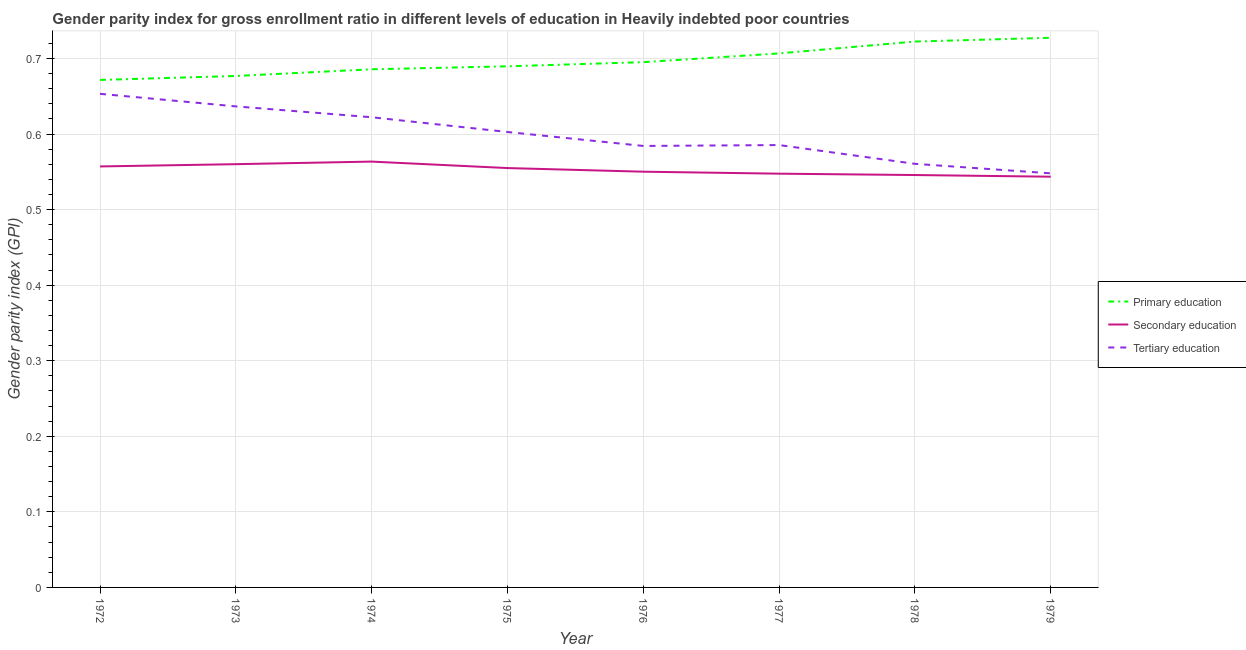What is the gender parity index in secondary education in 1976?
Provide a succinct answer. 0.55. Across all years, what is the maximum gender parity index in secondary education?
Keep it short and to the point. 0.56. Across all years, what is the minimum gender parity index in secondary education?
Provide a succinct answer. 0.54. In which year was the gender parity index in tertiary education minimum?
Make the answer very short. 1979. What is the total gender parity index in tertiary education in the graph?
Make the answer very short. 4.79. What is the difference between the gender parity index in secondary education in 1972 and that in 1974?
Your answer should be very brief. -0.01. What is the difference between the gender parity index in tertiary education in 1977 and the gender parity index in secondary education in 1973?
Your response must be concise. 0.03. What is the average gender parity index in tertiary education per year?
Keep it short and to the point. 0.6. In the year 1972, what is the difference between the gender parity index in secondary education and gender parity index in tertiary education?
Make the answer very short. -0.1. What is the ratio of the gender parity index in tertiary education in 1973 to that in 1976?
Ensure brevity in your answer.  1.09. Is the gender parity index in secondary education in 1974 less than that in 1976?
Your answer should be compact. No. Is the difference between the gender parity index in primary education in 1972 and 1977 greater than the difference between the gender parity index in tertiary education in 1972 and 1977?
Offer a terse response. No. What is the difference between the highest and the second highest gender parity index in tertiary education?
Provide a succinct answer. 0.02. What is the difference between the highest and the lowest gender parity index in secondary education?
Give a very brief answer. 0.02. Is the sum of the gender parity index in primary education in 1978 and 1979 greater than the maximum gender parity index in tertiary education across all years?
Provide a short and direct response. Yes. Is it the case that in every year, the sum of the gender parity index in primary education and gender parity index in secondary education is greater than the gender parity index in tertiary education?
Your answer should be compact. Yes. Is the gender parity index in primary education strictly less than the gender parity index in secondary education over the years?
Your answer should be compact. No. What is the difference between two consecutive major ticks on the Y-axis?
Give a very brief answer. 0.1. Are the values on the major ticks of Y-axis written in scientific E-notation?
Keep it short and to the point. No. Does the graph contain any zero values?
Make the answer very short. No. Where does the legend appear in the graph?
Provide a short and direct response. Center right. How are the legend labels stacked?
Provide a short and direct response. Vertical. What is the title of the graph?
Your answer should be very brief. Gender parity index for gross enrollment ratio in different levels of education in Heavily indebted poor countries. What is the label or title of the X-axis?
Your response must be concise. Year. What is the label or title of the Y-axis?
Ensure brevity in your answer.  Gender parity index (GPI). What is the Gender parity index (GPI) in Primary education in 1972?
Provide a succinct answer. 0.67. What is the Gender parity index (GPI) of Secondary education in 1972?
Give a very brief answer. 0.56. What is the Gender parity index (GPI) in Tertiary education in 1972?
Keep it short and to the point. 0.65. What is the Gender parity index (GPI) in Primary education in 1973?
Ensure brevity in your answer.  0.68. What is the Gender parity index (GPI) in Secondary education in 1973?
Offer a very short reply. 0.56. What is the Gender parity index (GPI) of Tertiary education in 1973?
Your answer should be very brief. 0.64. What is the Gender parity index (GPI) in Primary education in 1974?
Offer a very short reply. 0.69. What is the Gender parity index (GPI) in Secondary education in 1974?
Ensure brevity in your answer.  0.56. What is the Gender parity index (GPI) in Tertiary education in 1974?
Keep it short and to the point. 0.62. What is the Gender parity index (GPI) of Primary education in 1975?
Offer a very short reply. 0.69. What is the Gender parity index (GPI) of Secondary education in 1975?
Give a very brief answer. 0.56. What is the Gender parity index (GPI) of Tertiary education in 1975?
Offer a terse response. 0.6. What is the Gender parity index (GPI) in Primary education in 1976?
Give a very brief answer. 0.7. What is the Gender parity index (GPI) in Secondary education in 1976?
Give a very brief answer. 0.55. What is the Gender parity index (GPI) of Tertiary education in 1976?
Ensure brevity in your answer.  0.58. What is the Gender parity index (GPI) in Primary education in 1977?
Provide a succinct answer. 0.71. What is the Gender parity index (GPI) in Secondary education in 1977?
Your response must be concise. 0.55. What is the Gender parity index (GPI) of Tertiary education in 1977?
Offer a terse response. 0.59. What is the Gender parity index (GPI) in Primary education in 1978?
Ensure brevity in your answer.  0.72. What is the Gender parity index (GPI) of Secondary education in 1978?
Make the answer very short. 0.55. What is the Gender parity index (GPI) of Tertiary education in 1978?
Offer a very short reply. 0.56. What is the Gender parity index (GPI) in Primary education in 1979?
Provide a short and direct response. 0.73. What is the Gender parity index (GPI) in Secondary education in 1979?
Your response must be concise. 0.54. What is the Gender parity index (GPI) in Tertiary education in 1979?
Keep it short and to the point. 0.55. Across all years, what is the maximum Gender parity index (GPI) in Primary education?
Provide a succinct answer. 0.73. Across all years, what is the maximum Gender parity index (GPI) of Secondary education?
Offer a terse response. 0.56. Across all years, what is the maximum Gender parity index (GPI) in Tertiary education?
Your response must be concise. 0.65. Across all years, what is the minimum Gender parity index (GPI) of Primary education?
Your answer should be very brief. 0.67. Across all years, what is the minimum Gender parity index (GPI) of Secondary education?
Provide a short and direct response. 0.54. Across all years, what is the minimum Gender parity index (GPI) of Tertiary education?
Your answer should be compact. 0.55. What is the total Gender parity index (GPI) of Primary education in the graph?
Your response must be concise. 5.58. What is the total Gender parity index (GPI) in Secondary education in the graph?
Make the answer very short. 4.42. What is the total Gender parity index (GPI) in Tertiary education in the graph?
Your answer should be compact. 4.79. What is the difference between the Gender parity index (GPI) of Primary education in 1972 and that in 1973?
Make the answer very short. -0.01. What is the difference between the Gender parity index (GPI) of Secondary education in 1972 and that in 1973?
Offer a terse response. -0. What is the difference between the Gender parity index (GPI) in Tertiary education in 1972 and that in 1973?
Your answer should be very brief. 0.02. What is the difference between the Gender parity index (GPI) of Primary education in 1972 and that in 1974?
Ensure brevity in your answer.  -0.01. What is the difference between the Gender parity index (GPI) in Secondary education in 1972 and that in 1974?
Your response must be concise. -0.01. What is the difference between the Gender parity index (GPI) of Tertiary education in 1972 and that in 1974?
Your response must be concise. 0.03. What is the difference between the Gender parity index (GPI) in Primary education in 1972 and that in 1975?
Your answer should be very brief. -0.02. What is the difference between the Gender parity index (GPI) in Secondary education in 1972 and that in 1975?
Provide a short and direct response. 0. What is the difference between the Gender parity index (GPI) in Tertiary education in 1972 and that in 1975?
Give a very brief answer. 0.05. What is the difference between the Gender parity index (GPI) of Primary education in 1972 and that in 1976?
Make the answer very short. -0.02. What is the difference between the Gender parity index (GPI) in Secondary education in 1972 and that in 1976?
Your response must be concise. 0.01. What is the difference between the Gender parity index (GPI) in Tertiary education in 1972 and that in 1976?
Keep it short and to the point. 0.07. What is the difference between the Gender parity index (GPI) in Primary education in 1972 and that in 1977?
Your response must be concise. -0.04. What is the difference between the Gender parity index (GPI) in Secondary education in 1972 and that in 1977?
Make the answer very short. 0.01. What is the difference between the Gender parity index (GPI) of Tertiary education in 1972 and that in 1977?
Your response must be concise. 0.07. What is the difference between the Gender parity index (GPI) in Primary education in 1972 and that in 1978?
Make the answer very short. -0.05. What is the difference between the Gender parity index (GPI) in Secondary education in 1972 and that in 1978?
Provide a short and direct response. 0.01. What is the difference between the Gender parity index (GPI) in Tertiary education in 1972 and that in 1978?
Provide a succinct answer. 0.09. What is the difference between the Gender parity index (GPI) of Primary education in 1972 and that in 1979?
Give a very brief answer. -0.06. What is the difference between the Gender parity index (GPI) of Secondary education in 1972 and that in 1979?
Keep it short and to the point. 0.01. What is the difference between the Gender parity index (GPI) in Tertiary education in 1972 and that in 1979?
Make the answer very short. 0.11. What is the difference between the Gender parity index (GPI) in Primary education in 1973 and that in 1974?
Your response must be concise. -0.01. What is the difference between the Gender parity index (GPI) in Secondary education in 1973 and that in 1974?
Your response must be concise. -0. What is the difference between the Gender parity index (GPI) in Tertiary education in 1973 and that in 1974?
Offer a very short reply. 0.01. What is the difference between the Gender parity index (GPI) in Primary education in 1973 and that in 1975?
Ensure brevity in your answer.  -0.01. What is the difference between the Gender parity index (GPI) of Secondary education in 1973 and that in 1975?
Offer a very short reply. 0.01. What is the difference between the Gender parity index (GPI) of Tertiary education in 1973 and that in 1975?
Give a very brief answer. 0.03. What is the difference between the Gender parity index (GPI) of Primary education in 1973 and that in 1976?
Offer a terse response. -0.02. What is the difference between the Gender parity index (GPI) of Secondary education in 1973 and that in 1976?
Your answer should be very brief. 0.01. What is the difference between the Gender parity index (GPI) of Tertiary education in 1973 and that in 1976?
Your answer should be compact. 0.05. What is the difference between the Gender parity index (GPI) of Primary education in 1973 and that in 1977?
Offer a terse response. -0.03. What is the difference between the Gender parity index (GPI) in Secondary education in 1973 and that in 1977?
Ensure brevity in your answer.  0.01. What is the difference between the Gender parity index (GPI) of Tertiary education in 1973 and that in 1977?
Offer a very short reply. 0.05. What is the difference between the Gender parity index (GPI) in Primary education in 1973 and that in 1978?
Offer a terse response. -0.05. What is the difference between the Gender parity index (GPI) in Secondary education in 1973 and that in 1978?
Provide a short and direct response. 0.01. What is the difference between the Gender parity index (GPI) of Tertiary education in 1973 and that in 1978?
Offer a terse response. 0.08. What is the difference between the Gender parity index (GPI) of Primary education in 1973 and that in 1979?
Offer a very short reply. -0.05. What is the difference between the Gender parity index (GPI) of Secondary education in 1973 and that in 1979?
Offer a very short reply. 0.02. What is the difference between the Gender parity index (GPI) in Tertiary education in 1973 and that in 1979?
Your answer should be very brief. 0.09. What is the difference between the Gender parity index (GPI) of Primary education in 1974 and that in 1975?
Offer a very short reply. -0. What is the difference between the Gender parity index (GPI) in Secondary education in 1974 and that in 1975?
Offer a very short reply. 0.01. What is the difference between the Gender parity index (GPI) in Tertiary education in 1974 and that in 1975?
Your answer should be compact. 0.02. What is the difference between the Gender parity index (GPI) of Primary education in 1974 and that in 1976?
Give a very brief answer. -0.01. What is the difference between the Gender parity index (GPI) of Secondary education in 1974 and that in 1976?
Keep it short and to the point. 0.01. What is the difference between the Gender parity index (GPI) in Tertiary education in 1974 and that in 1976?
Provide a succinct answer. 0.04. What is the difference between the Gender parity index (GPI) of Primary education in 1974 and that in 1977?
Your response must be concise. -0.02. What is the difference between the Gender parity index (GPI) of Secondary education in 1974 and that in 1977?
Your answer should be compact. 0.02. What is the difference between the Gender parity index (GPI) in Tertiary education in 1974 and that in 1977?
Ensure brevity in your answer.  0.04. What is the difference between the Gender parity index (GPI) of Primary education in 1974 and that in 1978?
Ensure brevity in your answer.  -0.04. What is the difference between the Gender parity index (GPI) of Secondary education in 1974 and that in 1978?
Offer a very short reply. 0.02. What is the difference between the Gender parity index (GPI) in Tertiary education in 1974 and that in 1978?
Provide a succinct answer. 0.06. What is the difference between the Gender parity index (GPI) of Primary education in 1974 and that in 1979?
Keep it short and to the point. -0.04. What is the difference between the Gender parity index (GPI) of Tertiary education in 1974 and that in 1979?
Keep it short and to the point. 0.07. What is the difference between the Gender parity index (GPI) in Primary education in 1975 and that in 1976?
Make the answer very short. -0.01. What is the difference between the Gender parity index (GPI) in Secondary education in 1975 and that in 1976?
Give a very brief answer. 0. What is the difference between the Gender parity index (GPI) of Tertiary education in 1975 and that in 1976?
Ensure brevity in your answer.  0.02. What is the difference between the Gender parity index (GPI) in Primary education in 1975 and that in 1977?
Offer a terse response. -0.02. What is the difference between the Gender parity index (GPI) of Secondary education in 1975 and that in 1977?
Your answer should be compact. 0.01. What is the difference between the Gender parity index (GPI) of Tertiary education in 1975 and that in 1977?
Offer a terse response. 0.02. What is the difference between the Gender parity index (GPI) of Primary education in 1975 and that in 1978?
Make the answer very short. -0.03. What is the difference between the Gender parity index (GPI) of Secondary education in 1975 and that in 1978?
Your response must be concise. 0.01. What is the difference between the Gender parity index (GPI) in Tertiary education in 1975 and that in 1978?
Ensure brevity in your answer.  0.04. What is the difference between the Gender parity index (GPI) in Primary education in 1975 and that in 1979?
Ensure brevity in your answer.  -0.04. What is the difference between the Gender parity index (GPI) of Secondary education in 1975 and that in 1979?
Give a very brief answer. 0.01. What is the difference between the Gender parity index (GPI) in Tertiary education in 1975 and that in 1979?
Offer a very short reply. 0.05. What is the difference between the Gender parity index (GPI) in Primary education in 1976 and that in 1977?
Give a very brief answer. -0.01. What is the difference between the Gender parity index (GPI) of Secondary education in 1976 and that in 1977?
Give a very brief answer. 0. What is the difference between the Gender parity index (GPI) in Tertiary education in 1976 and that in 1977?
Your answer should be very brief. -0. What is the difference between the Gender parity index (GPI) in Primary education in 1976 and that in 1978?
Keep it short and to the point. -0.03. What is the difference between the Gender parity index (GPI) of Secondary education in 1976 and that in 1978?
Ensure brevity in your answer.  0. What is the difference between the Gender parity index (GPI) of Tertiary education in 1976 and that in 1978?
Give a very brief answer. 0.02. What is the difference between the Gender parity index (GPI) in Primary education in 1976 and that in 1979?
Provide a short and direct response. -0.03. What is the difference between the Gender parity index (GPI) of Secondary education in 1976 and that in 1979?
Give a very brief answer. 0.01. What is the difference between the Gender parity index (GPI) of Tertiary education in 1976 and that in 1979?
Provide a succinct answer. 0.04. What is the difference between the Gender parity index (GPI) in Primary education in 1977 and that in 1978?
Keep it short and to the point. -0.02. What is the difference between the Gender parity index (GPI) of Secondary education in 1977 and that in 1978?
Ensure brevity in your answer.  0. What is the difference between the Gender parity index (GPI) in Tertiary education in 1977 and that in 1978?
Give a very brief answer. 0.02. What is the difference between the Gender parity index (GPI) of Primary education in 1977 and that in 1979?
Your response must be concise. -0.02. What is the difference between the Gender parity index (GPI) of Secondary education in 1977 and that in 1979?
Keep it short and to the point. 0. What is the difference between the Gender parity index (GPI) in Tertiary education in 1977 and that in 1979?
Your response must be concise. 0.04. What is the difference between the Gender parity index (GPI) of Primary education in 1978 and that in 1979?
Your answer should be very brief. -0.01. What is the difference between the Gender parity index (GPI) of Secondary education in 1978 and that in 1979?
Ensure brevity in your answer.  0. What is the difference between the Gender parity index (GPI) of Tertiary education in 1978 and that in 1979?
Make the answer very short. 0.01. What is the difference between the Gender parity index (GPI) in Primary education in 1972 and the Gender parity index (GPI) in Secondary education in 1973?
Offer a terse response. 0.11. What is the difference between the Gender parity index (GPI) in Primary education in 1972 and the Gender parity index (GPI) in Tertiary education in 1973?
Your answer should be compact. 0.04. What is the difference between the Gender parity index (GPI) of Secondary education in 1972 and the Gender parity index (GPI) of Tertiary education in 1973?
Make the answer very short. -0.08. What is the difference between the Gender parity index (GPI) of Primary education in 1972 and the Gender parity index (GPI) of Secondary education in 1974?
Provide a succinct answer. 0.11. What is the difference between the Gender parity index (GPI) of Primary education in 1972 and the Gender parity index (GPI) of Tertiary education in 1974?
Your answer should be compact. 0.05. What is the difference between the Gender parity index (GPI) in Secondary education in 1972 and the Gender parity index (GPI) in Tertiary education in 1974?
Provide a short and direct response. -0.07. What is the difference between the Gender parity index (GPI) in Primary education in 1972 and the Gender parity index (GPI) in Secondary education in 1975?
Ensure brevity in your answer.  0.12. What is the difference between the Gender parity index (GPI) in Primary education in 1972 and the Gender parity index (GPI) in Tertiary education in 1975?
Ensure brevity in your answer.  0.07. What is the difference between the Gender parity index (GPI) in Secondary education in 1972 and the Gender parity index (GPI) in Tertiary education in 1975?
Your response must be concise. -0.05. What is the difference between the Gender parity index (GPI) in Primary education in 1972 and the Gender parity index (GPI) in Secondary education in 1976?
Offer a very short reply. 0.12. What is the difference between the Gender parity index (GPI) in Primary education in 1972 and the Gender parity index (GPI) in Tertiary education in 1976?
Provide a succinct answer. 0.09. What is the difference between the Gender parity index (GPI) of Secondary education in 1972 and the Gender parity index (GPI) of Tertiary education in 1976?
Provide a succinct answer. -0.03. What is the difference between the Gender parity index (GPI) of Primary education in 1972 and the Gender parity index (GPI) of Secondary education in 1977?
Your answer should be compact. 0.12. What is the difference between the Gender parity index (GPI) of Primary education in 1972 and the Gender parity index (GPI) of Tertiary education in 1977?
Make the answer very short. 0.09. What is the difference between the Gender parity index (GPI) in Secondary education in 1972 and the Gender parity index (GPI) in Tertiary education in 1977?
Your answer should be compact. -0.03. What is the difference between the Gender parity index (GPI) in Primary education in 1972 and the Gender parity index (GPI) in Secondary education in 1978?
Give a very brief answer. 0.13. What is the difference between the Gender parity index (GPI) in Primary education in 1972 and the Gender parity index (GPI) in Tertiary education in 1978?
Your answer should be compact. 0.11. What is the difference between the Gender parity index (GPI) in Secondary education in 1972 and the Gender parity index (GPI) in Tertiary education in 1978?
Ensure brevity in your answer.  -0. What is the difference between the Gender parity index (GPI) in Primary education in 1972 and the Gender parity index (GPI) in Secondary education in 1979?
Your answer should be very brief. 0.13. What is the difference between the Gender parity index (GPI) of Primary education in 1972 and the Gender parity index (GPI) of Tertiary education in 1979?
Your answer should be very brief. 0.12. What is the difference between the Gender parity index (GPI) of Secondary education in 1972 and the Gender parity index (GPI) of Tertiary education in 1979?
Your answer should be very brief. 0.01. What is the difference between the Gender parity index (GPI) in Primary education in 1973 and the Gender parity index (GPI) in Secondary education in 1974?
Provide a short and direct response. 0.11. What is the difference between the Gender parity index (GPI) in Primary education in 1973 and the Gender parity index (GPI) in Tertiary education in 1974?
Give a very brief answer. 0.05. What is the difference between the Gender parity index (GPI) in Secondary education in 1973 and the Gender parity index (GPI) in Tertiary education in 1974?
Offer a very short reply. -0.06. What is the difference between the Gender parity index (GPI) of Primary education in 1973 and the Gender parity index (GPI) of Secondary education in 1975?
Make the answer very short. 0.12. What is the difference between the Gender parity index (GPI) of Primary education in 1973 and the Gender parity index (GPI) of Tertiary education in 1975?
Your answer should be compact. 0.07. What is the difference between the Gender parity index (GPI) in Secondary education in 1973 and the Gender parity index (GPI) in Tertiary education in 1975?
Keep it short and to the point. -0.04. What is the difference between the Gender parity index (GPI) of Primary education in 1973 and the Gender parity index (GPI) of Secondary education in 1976?
Offer a very short reply. 0.13. What is the difference between the Gender parity index (GPI) in Primary education in 1973 and the Gender parity index (GPI) in Tertiary education in 1976?
Make the answer very short. 0.09. What is the difference between the Gender parity index (GPI) of Secondary education in 1973 and the Gender parity index (GPI) of Tertiary education in 1976?
Keep it short and to the point. -0.02. What is the difference between the Gender parity index (GPI) of Primary education in 1973 and the Gender parity index (GPI) of Secondary education in 1977?
Offer a terse response. 0.13. What is the difference between the Gender parity index (GPI) in Primary education in 1973 and the Gender parity index (GPI) in Tertiary education in 1977?
Offer a terse response. 0.09. What is the difference between the Gender parity index (GPI) of Secondary education in 1973 and the Gender parity index (GPI) of Tertiary education in 1977?
Offer a very short reply. -0.03. What is the difference between the Gender parity index (GPI) of Primary education in 1973 and the Gender parity index (GPI) of Secondary education in 1978?
Keep it short and to the point. 0.13. What is the difference between the Gender parity index (GPI) in Primary education in 1973 and the Gender parity index (GPI) in Tertiary education in 1978?
Give a very brief answer. 0.12. What is the difference between the Gender parity index (GPI) in Secondary education in 1973 and the Gender parity index (GPI) in Tertiary education in 1978?
Keep it short and to the point. -0. What is the difference between the Gender parity index (GPI) of Primary education in 1973 and the Gender parity index (GPI) of Secondary education in 1979?
Your response must be concise. 0.13. What is the difference between the Gender parity index (GPI) of Primary education in 1973 and the Gender parity index (GPI) of Tertiary education in 1979?
Offer a very short reply. 0.13. What is the difference between the Gender parity index (GPI) in Secondary education in 1973 and the Gender parity index (GPI) in Tertiary education in 1979?
Give a very brief answer. 0.01. What is the difference between the Gender parity index (GPI) in Primary education in 1974 and the Gender parity index (GPI) in Secondary education in 1975?
Your response must be concise. 0.13. What is the difference between the Gender parity index (GPI) in Primary education in 1974 and the Gender parity index (GPI) in Tertiary education in 1975?
Your response must be concise. 0.08. What is the difference between the Gender parity index (GPI) of Secondary education in 1974 and the Gender parity index (GPI) of Tertiary education in 1975?
Make the answer very short. -0.04. What is the difference between the Gender parity index (GPI) in Primary education in 1974 and the Gender parity index (GPI) in Secondary education in 1976?
Make the answer very short. 0.14. What is the difference between the Gender parity index (GPI) of Primary education in 1974 and the Gender parity index (GPI) of Tertiary education in 1976?
Offer a very short reply. 0.1. What is the difference between the Gender parity index (GPI) in Secondary education in 1974 and the Gender parity index (GPI) in Tertiary education in 1976?
Your response must be concise. -0.02. What is the difference between the Gender parity index (GPI) in Primary education in 1974 and the Gender parity index (GPI) in Secondary education in 1977?
Give a very brief answer. 0.14. What is the difference between the Gender parity index (GPI) of Primary education in 1974 and the Gender parity index (GPI) of Tertiary education in 1977?
Keep it short and to the point. 0.1. What is the difference between the Gender parity index (GPI) of Secondary education in 1974 and the Gender parity index (GPI) of Tertiary education in 1977?
Your answer should be compact. -0.02. What is the difference between the Gender parity index (GPI) of Primary education in 1974 and the Gender parity index (GPI) of Secondary education in 1978?
Your answer should be compact. 0.14. What is the difference between the Gender parity index (GPI) in Primary education in 1974 and the Gender parity index (GPI) in Tertiary education in 1978?
Offer a very short reply. 0.13. What is the difference between the Gender parity index (GPI) in Secondary education in 1974 and the Gender parity index (GPI) in Tertiary education in 1978?
Your answer should be very brief. 0. What is the difference between the Gender parity index (GPI) in Primary education in 1974 and the Gender parity index (GPI) in Secondary education in 1979?
Offer a terse response. 0.14. What is the difference between the Gender parity index (GPI) in Primary education in 1974 and the Gender parity index (GPI) in Tertiary education in 1979?
Keep it short and to the point. 0.14. What is the difference between the Gender parity index (GPI) in Secondary education in 1974 and the Gender parity index (GPI) in Tertiary education in 1979?
Keep it short and to the point. 0.02. What is the difference between the Gender parity index (GPI) of Primary education in 1975 and the Gender parity index (GPI) of Secondary education in 1976?
Offer a terse response. 0.14. What is the difference between the Gender parity index (GPI) in Primary education in 1975 and the Gender parity index (GPI) in Tertiary education in 1976?
Make the answer very short. 0.11. What is the difference between the Gender parity index (GPI) of Secondary education in 1975 and the Gender parity index (GPI) of Tertiary education in 1976?
Provide a short and direct response. -0.03. What is the difference between the Gender parity index (GPI) in Primary education in 1975 and the Gender parity index (GPI) in Secondary education in 1977?
Offer a very short reply. 0.14. What is the difference between the Gender parity index (GPI) in Primary education in 1975 and the Gender parity index (GPI) in Tertiary education in 1977?
Keep it short and to the point. 0.1. What is the difference between the Gender parity index (GPI) in Secondary education in 1975 and the Gender parity index (GPI) in Tertiary education in 1977?
Provide a short and direct response. -0.03. What is the difference between the Gender parity index (GPI) in Primary education in 1975 and the Gender parity index (GPI) in Secondary education in 1978?
Your answer should be compact. 0.14. What is the difference between the Gender parity index (GPI) of Primary education in 1975 and the Gender parity index (GPI) of Tertiary education in 1978?
Your answer should be very brief. 0.13. What is the difference between the Gender parity index (GPI) in Secondary education in 1975 and the Gender parity index (GPI) in Tertiary education in 1978?
Provide a succinct answer. -0.01. What is the difference between the Gender parity index (GPI) of Primary education in 1975 and the Gender parity index (GPI) of Secondary education in 1979?
Offer a terse response. 0.15. What is the difference between the Gender parity index (GPI) in Primary education in 1975 and the Gender parity index (GPI) in Tertiary education in 1979?
Offer a very short reply. 0.14. What is the difference between the Gender parity index (GPI) in Secondary education in 1975 and the Gender parity index (GPI) in Tertiary education in 1979?
Keep it short and to the point. 0.01. What is the difference between the Gender parity index (GPI) of Primary education in 1976 and the Gender parity index (GPI) of Secondary education in 1977?
Provide a succinct answer. 0.15. What is the difference between the Gender parity index (GPI) in Primary education in 1976 and the Gender parity index (GPI) in Tertiary education in 1977?
Your answer should be very brief. 0.11. What is the difference between the Gender parity index (GPI) of Secondary education in 1976 and the Gender parity index (GPI) of Tertiary education in 1977?
Provide a succinct answer. -0.04. What is the difference between the Gender parity index (GPI) in Primary education in 1976 and the Gender parity index (GPI) in Secondary education in 1978?
Your answer should be compact. 0.15. What is the difference between the Gender parity index (GPI) of Primary education in 1976 and the Gender parity index (GPI) of Tertiary education in 1978?
Make the answer very short. 0.13. What is the difference between the Gender parity index (GPI) in Secondary education in 1976 and the Gender parity index (GPI) in Tertiary education in 1978?
Your response must be concise. -0.01. What is the difference between the Gender parity index (GPI) of Primary education in 1976 and the Gender parity index (GPI) of Secondary education in 1979?
Give a very brief answer. 0.15. What is the difference between the Gender parity index (GPI) in Primary education in 1976 and the Gender parity index (GPI) in Tertiary education in 1979?
Provide a short and direct response. 0.15. What is the difference between the Gender parity index (GPI) in Secondary education in 1976 and the Gender parity index (GPI) in Tertiary education in 1979?
Make the answer very short. 0. What is the difference between the Gender parity index (GPI) in Primary education in 1977 and the Gender parity index (GPI) in Secondary education in 1978?
Provide a succinct answer. 0.16. What is the difference between the Gender parity index (GPI) of Primary education in 1977 and the Gender parity index (GPI) of Tertiary education in 1978?
Offer a terse response. 0.15. What is the difference between the Gender parity index (GPI) of Secondary education in 1977 and the Gender parity index (GPI) of Tertiary education in 1978?
Provide a short and direct response. -0.01. What is the difference between the Gender parity index (GPI) in Primary education in 1977 and the Gender parity index (GPI) in Secondary education in 1979?
Give a very brief answer. 0.16. What is the difference between the Gender parity index (GPI) in Primary education in 1977 and the Gender parity index (GPI) in Tertiary education in 1979?
Provide a short and direct response. 0.16. What is the difference between the Gender parity index (GPI) in Secondary education in 1977 and the Gender parity index (GPI) in Tertiary education in 1979?
Keep it short and to the point. -0. What is the difference between the Gender parity index (GPI) in Primary education in 1978 and the Gender parity index (GPI) in Secondary education in 1979?
Ensure brevity in your answer.  0.18. What is the difference between the Gender parity index (GPI) in Primary education in 1978 and the Gender parity index (GPI) in Tertiary education in 1979?
Give a very brief answer. 0.17. What is the difference between the Gender parity index (GPI) in Secondary education in 1978 and the Gender parity index (GPI) in Tertiary education in 1979?
Your answer should be compact. -0. What is the average Gender parity index (GPI) in Primary education per year?
Keep it short and to the point. 0.7. What is the average Gender parity index (GPI) in Secondary education per year?
Provide a succinct answer. 0.55. What is the average Gender parity index (GPI) of Tertiary education per year?
Offer a very short reply. 0.6. In the year 1972, what is the difference between the Gender parity index (GPI) in Primary education and Gender parity index (GPI) in Secondary education?
Provide a short and direct response. 0.11. In the year 1972, what is the difference between the Gender parity index (GPI) in Primary education and Gender parity index (GPI) in Tertiary education?
Your response must be concise. 0.02. In the year 1972, what is the difference between the Gender parity index (GPI) in Secondary education and Gender parity index (GPI) in Tertiary education?
Your response must be concise. -0.1. In the year 1973, what is the difference between the Gender parity index (GPI) of Primary education and Gender parity index (GPI) of Secondary education?
Offer a terse response. 0.12. In the year 1973, what is the difference between the Gender parity index (GPI) of Primary education and Gender parity index (GPI) of Tertiary education?
Your answer should be compact. 0.04. In the year 1973, what is the difference between the Gender parity index (GPI) in Secondary education and Gender parity index (GPI) in Tertiary education?
Offer a terse response. -0.08. In the year 1974, what is the difference between the Gender parity index (GPI) of Primary education and Gender parity index (GPI) of Secondary education?
Your response must be concise. 0.12. In the year 1974, what is the difference between the Gender parity index (GPI) in Primary education and Gender parity index (GPI) in Tertiary education?
Ensure brevity in your answer.  0.06. In the year 1974, what is the difference between the Gender parity index (GPI) in Secondary education and Gender parity index (GPI) in Tertiary education?
Your response must be concise. -0.06. In the year 1975, what is the difference between the Gender parity index (GPI) in Primary education and Gender parity index (GPI) in Secondary education?
Provide a succinct answer. 0.13. In the year 1975, what is the difference between the Gender parity index (GPI) in Primary education and Gender parity index (GPI) in Tertiary education?
Your response must be concise. 0.09. In the year 1975, what is the difference between the Gender parity index (GPI) of Secondary education and Gender parity index (GPI) of Tertiary education?
Your answer should be compact. -0.05. In the year 1976, what is the difference between the Gender parity index (GPI) in Primary education and Gender parity index (GPI) in Secondary education?
Your answer should be very brief. 0.14. In the year 1976, what is the difference between the Gender parity index (GPI) of Primary education and Gender parity index (GPI) of Tertiary education?
Offer a very short reply. 0.11. In the year 1976, what is the difference between the Gender parity index (GPI) of Secondary education and Gender parity index (GPI) of Tertiary education?
Offer a terse response. -0.03. In the year 1977, what is the difference between the Gender parity index (GPI) in Primary education and Gender parity index (GPI) in Secondary education?
Give a very brief answer. 0.16. In the year 1977, what is the difference between the Gender parity index (GPI) in Primary education and Gender parity index (GPI) in Tertiary education?
Provide a short and direct response. 0.12. In the year 1977, what is the difference between the Gender parity index (GPI) in Secondary education and Gender parity index (GPI) in Tertiary education?
Offer a terse response. -0.04. In the year 1978, what is the difference between the Gender parity index (GPI) in Primary education and Gender parity index (GPI) in Secondary education?
Make the answer very short. 0.18. In the year 1978, what is the difference between the Gender parity index (GPI) of Primary education and Gender parity index (GPI) of Tertiary education?
Ensure brevity in your answer.  0.16. In the year 1978, what is the difference between the Gender parity index (GPI) in Secondary education and Gender parity index (GPI) in Tertiary education?
Make the answer very short. -0.01. In the year 1979, what is the difference between the Gender parity index (GPI) of Primary education and Gender parity index (GPI) of Secondary education?
Your answer should be compact. 0.18. In the year 1979, what is the difference between the Gender parity index (GPI) of Primary education and Gender parity index (GPI) of Tertiary education?
Ensure brevity in your answer.  0.18. In the year 1979, what is the difference between the Gender parity index (GPI) in Secondary education and Gender parity index (GPI) in Tertiary education?
Offer a terse response. -0. What is the ratio of the Gender parity index (GPI) in Tertiary education in 1972 to that in 1973?
Ensure brevity in your answer.  1.03. What is the ratio of the Gender parity index (GPI) in Primary education in 1972 to that in 1974?
Give a very brief answer. 0.98. What is the ratio of the Gender parity index (GPI) of Tertiary education in 1972 to that in 1974?
Give a very brief answer. 1.05. What is the ratio of the Gender parity index (GPI) of Primary education in 1972 to that in 1975?
Provide a succinct answer. 0.97. What is the ratio of the Gender parity index (GPI) of Secondary education in 1972 to that in 1975?
Your response must be concise. 1. What is the ratio of the Gender parity index (GPI) of Tertiary education in 1972 to that in 1975?
Keep it short and to the point. 1.08. What is the ratio of the Gender parity index (GPI) of Primary education in 1972 to that in 1976?
Offer a very short reply. 0.97. What is the ratio of the Gender parity index (GPI) in Secondary education in 1972 to that in 1976?
Make the answer very short. 1.01. What is the ratio of the Gender parity index (GPI) of Tertiary education in 1972 to that in 1976?
Offer a very short reply. 1.12. What is the ratio of the Gender parity index (GPI) of Primary education in 1972 to that in 1977?
Provide a succinct answer. 0.95. What is the ratio of the Gender parity index (GPI) in Secondary education in 1972 to that in 1977?
Provide a succinct answer. 1.02. What is the ratio of the Gender parity index (GPI) of Tertiary education in 1972 to that in 1977?
Offer a very short reply. 1.12. What is the ratio of the Gender parity index (GPI) in Primary education in 1972 to that in 1978?
Keep it short and to the point. 0.93. What is the ratio of the Gender parity index (GPI) of Secondary education in 1972 to that in 1978?
Your answer should be compact. 1.02. What is the ratio of the Gender parity index (GPI) of Tertiary education in 1972 to that in 1978?
Make the answer very short. 1.17. What is the ratio of the Gender parity index (GPI) of Primary education in 1972 to that in 1979?
Your response must be concise. 0.92. What is the ratio of the Gender parity index (GPI) of Secondary education in 1972 to that in 1979?
Your answer should be compact. 1.02. What is the ratio of the Gender parity index (GPI) of Tertiary education in 1972 to that in 1979?
Provide a short and direct response. 1.19. What is the ratio of the Gender parity index (GPI) in Primary education in 1973 to that in 1974?
Your answer should be compact. 0.99. What is the ratio of the Gender parity index (GPI) of Secondary education in 1973 to that in 1974?
Provide a short and direct response. 0.99. What is the ratio of the Gender parity index (GPI) of Tertiary education in 1973 to that in 1974?
Make the answer very short. 1.02. What is the ratio of the Gender parity index (GPI) of Primary education in 1973 to that in 1975?
Offer a very short reply. 0.98. What is the ratio of the Gender parity index (GPI) of Secondary education in 1973 to that in 1975?
Your response must be concise. 1.01. What is the ratio of the Gender parity index (GPI) in Tertiary education in 1973 to that in 1975?
Make the answer very short. 1.06. What is the ratio of the Gender parity index (GPI) of Primary education in 1973 to that in 1976?
Offer a terse response. 0.97. What is the ratio of the Gender parity index (GPI) in Secondary education in 1973 to that in 1976?
Your response must be concise. 1.02. What is the ratio of the Gender parity index (GPI) in Tertiary education in 1973 to that in 1976?
Your response must be concise. 1.09. What is the ratio of the Gender parity index (GPI) in Primary education in 1973 to that in 1977?
Ensure brevity in your answer.  0.96. What is the ratio of the Gender parity index (GPI) in Tertiary education in 1973 to that in 1977?
Your response must be concise. 1.09. What is the ratio of the Gender parity index (GPI) in Primary education in 1973 to that in 1978?
Offer a very short reply. 0.94. What is the ratio of the Gender parity index (GPI) in Secondary education in 1973 to that in 1978?
Keep it short and to the point. 1.03. What is the ratio of the Gender parity index (GPI) in Tertiary education in 1973 to that in 1978?
Provide a succinct answer. 1.14. What is the ratio of the Gender parity index (GPI) of Primary education in 1973 to that in 1979?
Provide a succinct answer. 0.93. What is the ratio of the Gender parity index (GPI) in Secondary education in 1973 to that in 1979?
Keep it short and to the point. 1.03. What is the ratio of the Gender parity index (GPI) in Tertiary education in 1973 to that in 1979?
Make the answer very short. 1.16. What is the ratio of the Gender parity index (GPI) in Primary education in 1974 to that in 1975?
Provide a short and direct response. 0.99. What is the ratio of the Gender parity index (GPI) in Secondary education in 1974 to that in 1975?
Make the answer very short. 1.02. What is the ratio of the Gender parity index (GPI) in Tertiary education in 1974 to that in 1975?
Offer a very short reply. 1.03. What is the ratio of the Gender parity index (GPI) in Primary education in 1974 to that in 1976?
Provide a short and direct response. 0.99. What is the ratio of the Gender parity index (GPI) of Secondary education in 1974 to that in 1976?
Keep it short and to the point. 1.02. What is the ratio of the Gender parity index (GPI) of Tertiary education in 1974 to that in 1976?
Give a very brief answer. 1.06. What is the ratio of the Gender parity index (GPI) in Primary education in 1974 to that in 1977?
Give a very brief answer. 0.97. What is the ratio of the Gender parity index (GPI) of Secondary education in 1974 to that in 1977?
Offer a terse response. 1.03. What is the ratio of the Gender parity index (GPI) of Tertiary education in 1974 to that in 1977?
Keep it short and to the point. 1.06. What is the ratio of the Gender parity index (GPI) of Primary education in 1974 to that in 1978?
Make the answer very short. 0.95. What is the ratio of the Gender parity index (GPI) of Secondary education in 1974 to that in 1978?
Make the answer very short. 1.03. What is the ratio of the Gender parity index (GPI) in Tertiary education in 1974 to that in 1978?
Your response must be concise. 1.11. What is the ratio of the Gender parity index (GPI) of Primary education in 1974 to that in 1979?
Provide a succinct answer. 0.94. What is the ratio of the Gender parity index (GPI) in Secondary education in 1974 to that in 1979?
Provide a succinct answer. 1.04. What is the ratio of the Gender parity index (GPI) in Tertiary education in 1974 to that in 1979?
Your answer should be very brief. 1.14. What is the ratio of the Gender parity index (GPI) of Primary education in 1975 to that in 1976?
Your answer should be compact. 0.99. What is the ratio of the Gender parity index (GPI) in Secondary education in 1975 to that in 1976?
Your answer should be compact. 1.01. What is the ratio of the Gender parity index (GPI) in Tertiary education in 1975 to that in 1976?
Make the answer very short. 1.03. What is the ratio of the Gender parity index (GPI) of Primary education in 1975 to that in 1977?
Make the answer very short. 0.98. What is the ratio of the Gender parity index (GPI) in Secondary education in 1975 to that in 1977?
Ensure brevity in your answer.  1.01. What is the ratio of the Gender parity index (GPI) of Tertiary education in 1975 to that in 1977?
Your answer should be very brief. 1.03. What is the ratio of the Gender parity index (GPI) of Primary education in 1975 to that in 1978?
Offer a very short reply. 0.95. What is the ratio of the Gender parity index (GPI) in Secondary education in 1975 to that in 1978?
Your answer should be very brief. 1.02. What is the ratio of the Gender parity index (GPI) of Tertiary education in 1975 to that in 1978?
Offer a very short reply. 1.08. What is the ratio of the Gender parity index (GPI) in Primary education in 1975 to that in 1979?
Offer a very short reply. 0.95. What is the ratio of the Gender parity index (GPI) of Secondary education in 1975 to that in 1979?
Offer a terse response. 1.02. What is the ratio of the Gender parity index (GPI) in Tertiary education in 1975 to that in 1979?
Keep it short and to the point. 1.1. What is the ratio of the Gender parity index (GPI) in Primary education in 1976 to that in 1977?
Ensure brevity in your answer.  0.98. What is the ratio of the Gender parity index (GPI) of Primary education in 1976 to that in 1978?
Provide a succinct answer. 0.96. What is the ratio of the Gender parity index (GPI) of Secondary education in 1976 to that in 1978?
Provide a succinct answer. 1.01. What is the ratio of the Gender parity index (GPI) in Tertiary education in 1976 to that in 1978?
Keep it short and to the point. 1.04. What is the ratio of the Gender parity index (GPI) in Primary education in 1976 to that in 1979?
Make the answer very short. 0.96. What is the ratio of the Gender parity index (GPI) in Secondary education in 1976 to that in 1979?
Give a very brief answer. 1.01. What is the ratio of the Gender parity index (GPI) of Tertiary education in 1976 to that in 1979?
Provide a short and direct response. 1.07. What is the ratio of the Gender parity index (GPI) of Primary education in 1977 to that in 1978?
Give a very brief answer. 0.98. What is the ratio of the Gender parity index (GPI) of Secondary education in 1977 to that in 1978?
Offer a terse response. 1. What is the ratio of the Gender parity index (GPI) in Tertiary education in 1977 to that in 1978?
Keep it short and to the point. 1.04. What is the ratio of the Gender parity index (GPI) in Primary education in 1977 to that in 1979?
Your answer should be very brief. 0.97. What is the ratio of the Gender parity index (GPI) of Secondary education in 1977 to that in 1979?
Your answer should be very brief. 1.01. What is the ratio of the Gender parity index (GPI) in Tertiary education in 1977 to that in 1979?
Offer a very short reply. 1.07. What is the ratio of the Gender parity index (GPI) in Secondary education in 1978 to that in 1979?
Your response must be concise. 1. What is the ratio of the Gender parity index (GPI) of Tertiary education in 1978 to that in 1979?
Offer a very short reply. 1.02. What is the difference between the highest and the second highest Gender parity index (GPI) in Primary education?
Offer a terse response. 0.01. What is the difference between the highest and the second highest Gender parity index (GPI) of Secondary education?
Your answer should be very brief. 0. What is the difference between the highest and the second highest Gender parity index (GPI) in Tertiary education?
Ensure brevity in your answer.  0.02. What is the difference between the highest and the lowest Gender parity index (GPI) of Primary education?
Provide a succinct answer. 0.06. What is the difference between the highest and the lowest Gender parity index (GPI) in Secondary education?
Provide a succinct answer. 0.02. What is the difference between the highest and the lowest Gender parity index (GPI) in Tertiary education?
Keep it short and to the point. 0.11. 